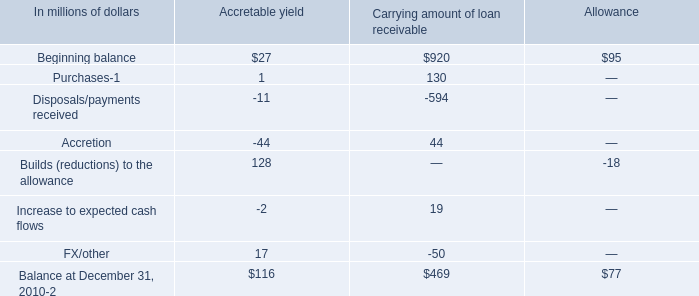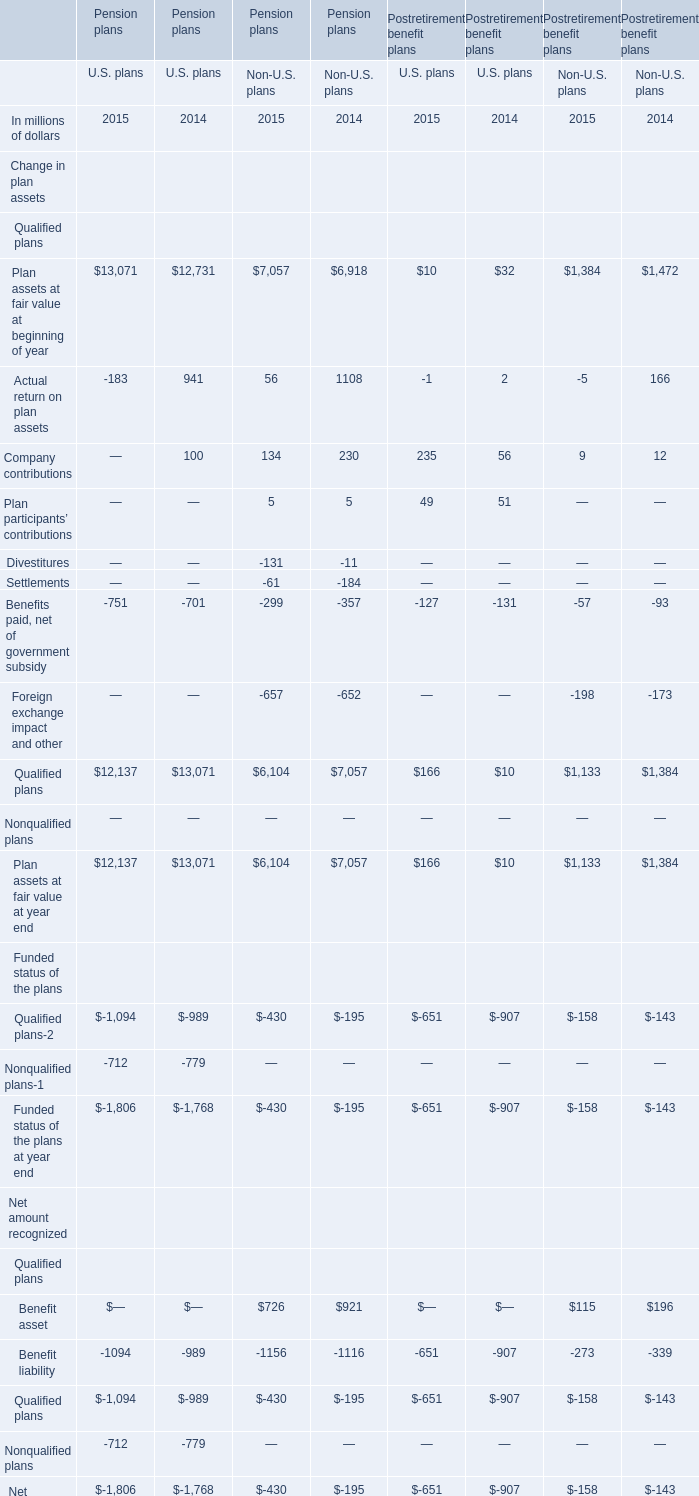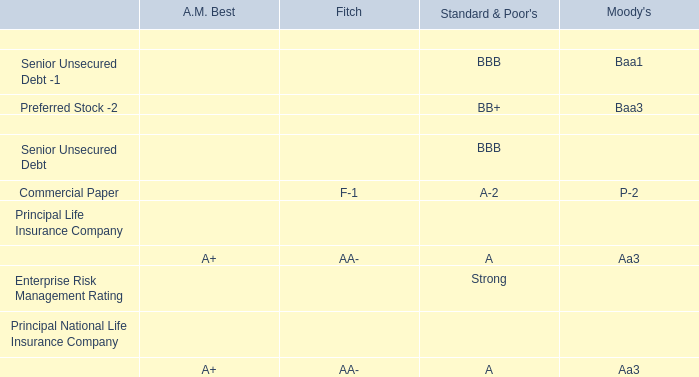at december 31 , 2010 what was the percent of the net allowance to the the carrying amount of the company 2019s purchased distressed loan portfolio 
Computations: (77 / 392)
Answer: 0.19643. 